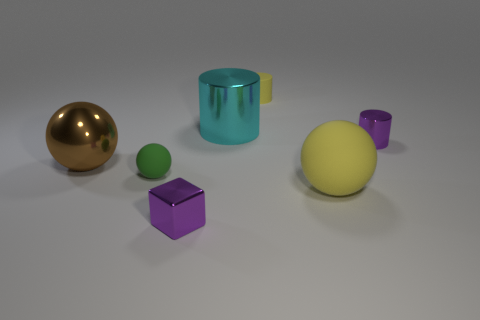Add 2 large things. How many objects exist? 9 Subtract all cylinders. How many objects are left? 4 Subtract 0 blue blocks. How many objects are left? 7 Subtract all big spheres. Subtract all brown objects. How many objects are left? 4 Add 3 small purple things. How many small purple things are left? 5 Add 4 shiny spheres. How many shiny spheres exist? 5 